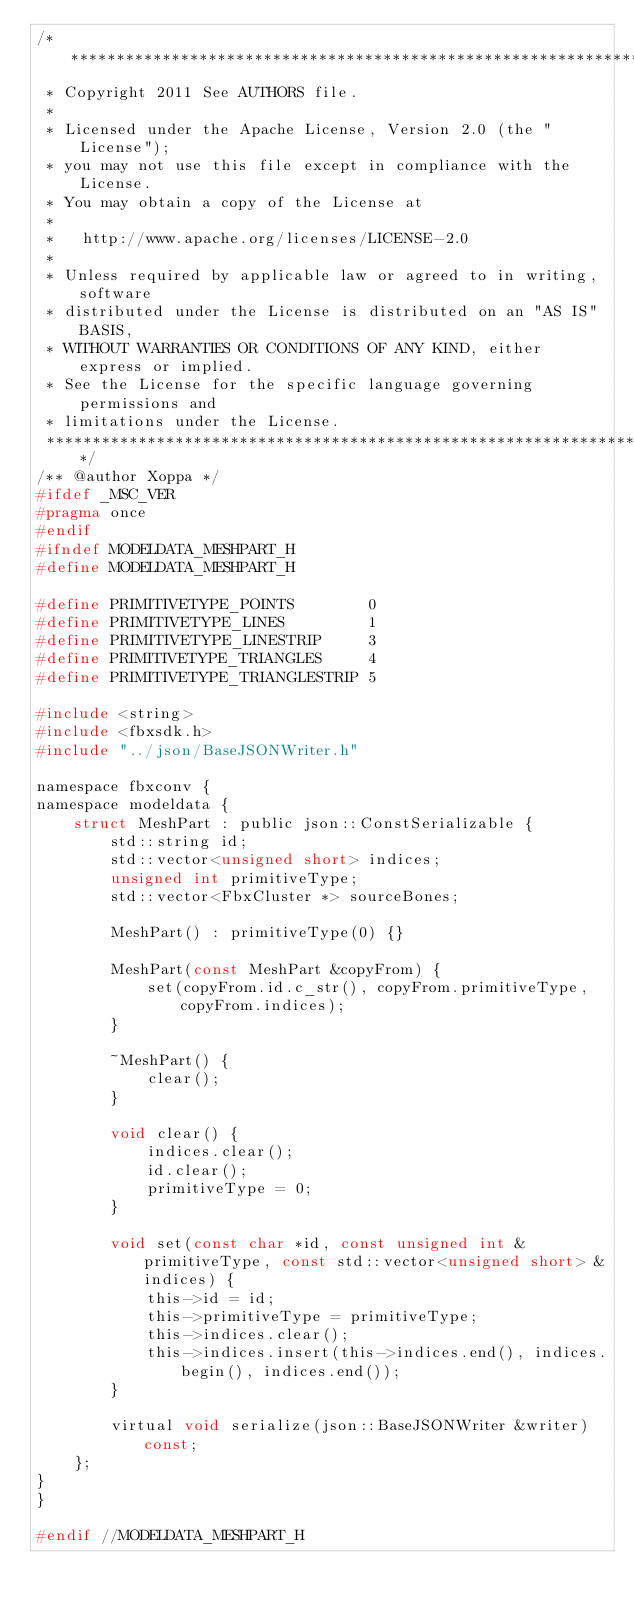Convert code to text. <code><loc_0><loc_0><loc_500><loc_500><_C_>/*******************************************************************************
 * Copyright 2011 See AUTHORS file.
 * 
 * Licensed under the Apache License, Version 2.0 (the "License");
 * you may not use this file except in compliance with the License.
 * You may obtain a copy of the License at
 * 
 *   http://www.apache.org/licenses/LICENSE-2.0
 * 
 * Unless required by applicable law or agreed to in writing, software
 * distributed under the License is distributed on an "AS IS" BASIS,
 * WITHOUT WARRANTIES OR CONDITIONS OF ANY KIND, either express or implied.
 * See the License for the specific language governing permissions and
 * limitations under the License.
 ******************************************************************************/
/** @author Xoppa */
#ifdef _MSC_VER 
#pragma once
#endif
#ifndef MODELDATA_MESHPART_H
#define MODELDATA_MESHPART_H

#define PRIMITIVETYPE_POINTS		0
#define PRIMITIVETYPE_LINES			1
#define PRIMITIVETYPE_LINESTRIP		3
#define PRIMITIVETYPE_TRIANGLES		4
#define PRIMITIVETYPE_TRIANGLESTRIP	5

#include <string>
#include <fbxsdk.h>
#include "../json/BaseJSONWriter.h"

namespace fbxconv {
namespace modeldata {
	struct MeshPart : public json::ConstSerializable {
		std::string id;
		std::vector<unsigned short> indices;
		unsigned int primitiveType;
		std::vector<FbxCluster *> sourceBones;

		MeshPart() : primitiveType(0) {}

		MeshPart(const MeshPart &copyFrom) {
			set(copyFrom.id.c_str(), copyFrom.primitiveType, copyFrom.indices);
		}

		~MeshPart() {
			clear();
		}

		void clear() {
			indices.clear();
			id.clear();
			primitiveType = 0;
		}

		void set(const char *id, const unsigned int &primitiveType, const std::vector<unsigned short> &indices) {
			this->id = id;
			this->primitiveType = primitiveType;
			this->indices.clear();
			this->indices.insert(this->indices.end(), indices.begin(), indices.end());
		}

		virtual void serialize(json::BaseJSONWriter &writer) const;
	};
}
}

#endif //MODELDATA_MESHPART_H</code> 